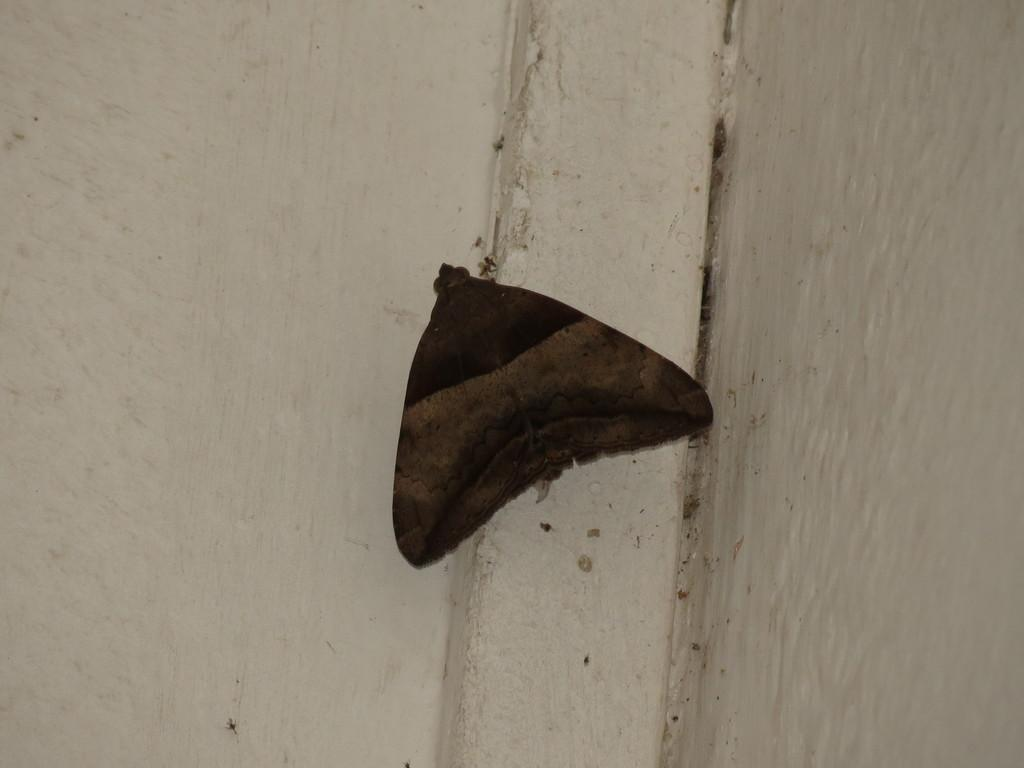What is present on the wall in the image? There is an insect on the wall in the image. What is the color of the wall? The wall is painted white. Is the insect wearing a collar in the image? There is no collar present in the image, as insects do not wear collars. 